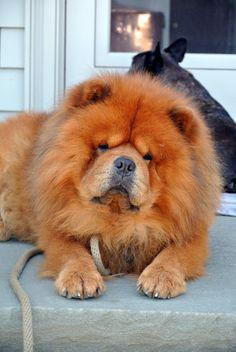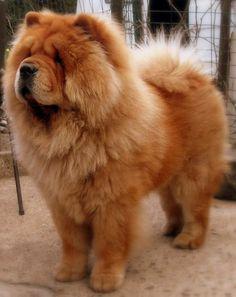The first image is the image on the left, the second image is the image on the right. Considering the images on both sides, is "One of the images contains a dog that is laying down." valid? Answer yes or no. Yes. 